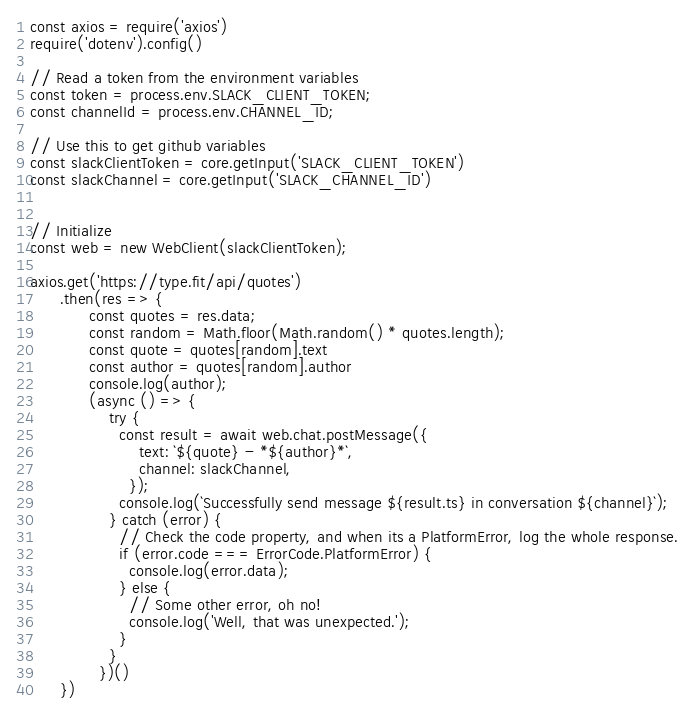<code> <loc_0><loc_0><loc_500><loc_500><_JavaScript_>
const axios = require('axios')
require('dotenv').config()

// Read a token from the environment variables
const token = process.env.SLACK_CLIENT_TOKEN;
const channelId = process.env.CHANNEL_ID;

// Use this to get github variables
const slackClientToken = core.getInput('SLACK_CLIENT_TOKEN')
const slackChannel = core.getInput('SLACK_CHANNEL_ID')


// Initialize
const web = new WebClient(slackClientToken);

axios.get('https://type.fit/api/quotes')
      .then(res => {
            const quotes = res.data;
            const random = Math.floor(Math.random() * quotes.length);
            const quote = quotes[random].text
            const author = quotes[random].author
            console.log(author);
            (async () => {
                try {
                  const result = await web.chat.postMessage({
                      text: `${quote} - *${author}*`,
                      channel: slackChannel,
                    });
                  console.log(`Successfully send message ${result.ts} in conversation ${channel}`);
                } catch (error) {
                  // Check the code property, and when its a PlatformError, log the whole response.
                  if (error.code === ErrorCode.PlatformError) {
                    console.log(error.data);
                  } else {
                    // Some other error, oh no!
                    console.log('Well, that was unexpected.');
                  }
                }
              })()
      })</code> 